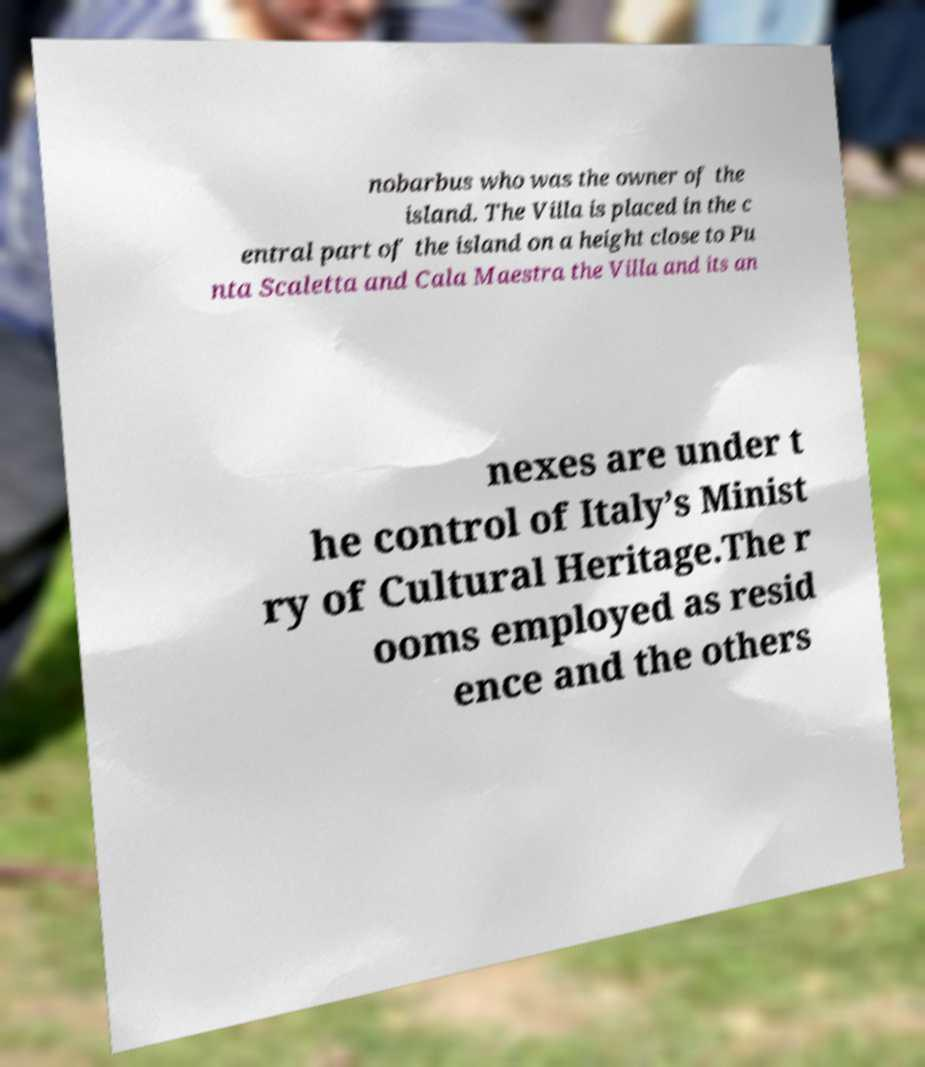I need the written content from this picture converted into text. Can you do that? nobarbus who was the owner of the island. The Villa is placed in the c entral part of the island on a height close to Pu nta Scaletta and Cala Maestra the Villa and its an nexes are under t he control of Italy’s Minist ry of Cultural Heritage.The r ooms employed as resid ence and the others 